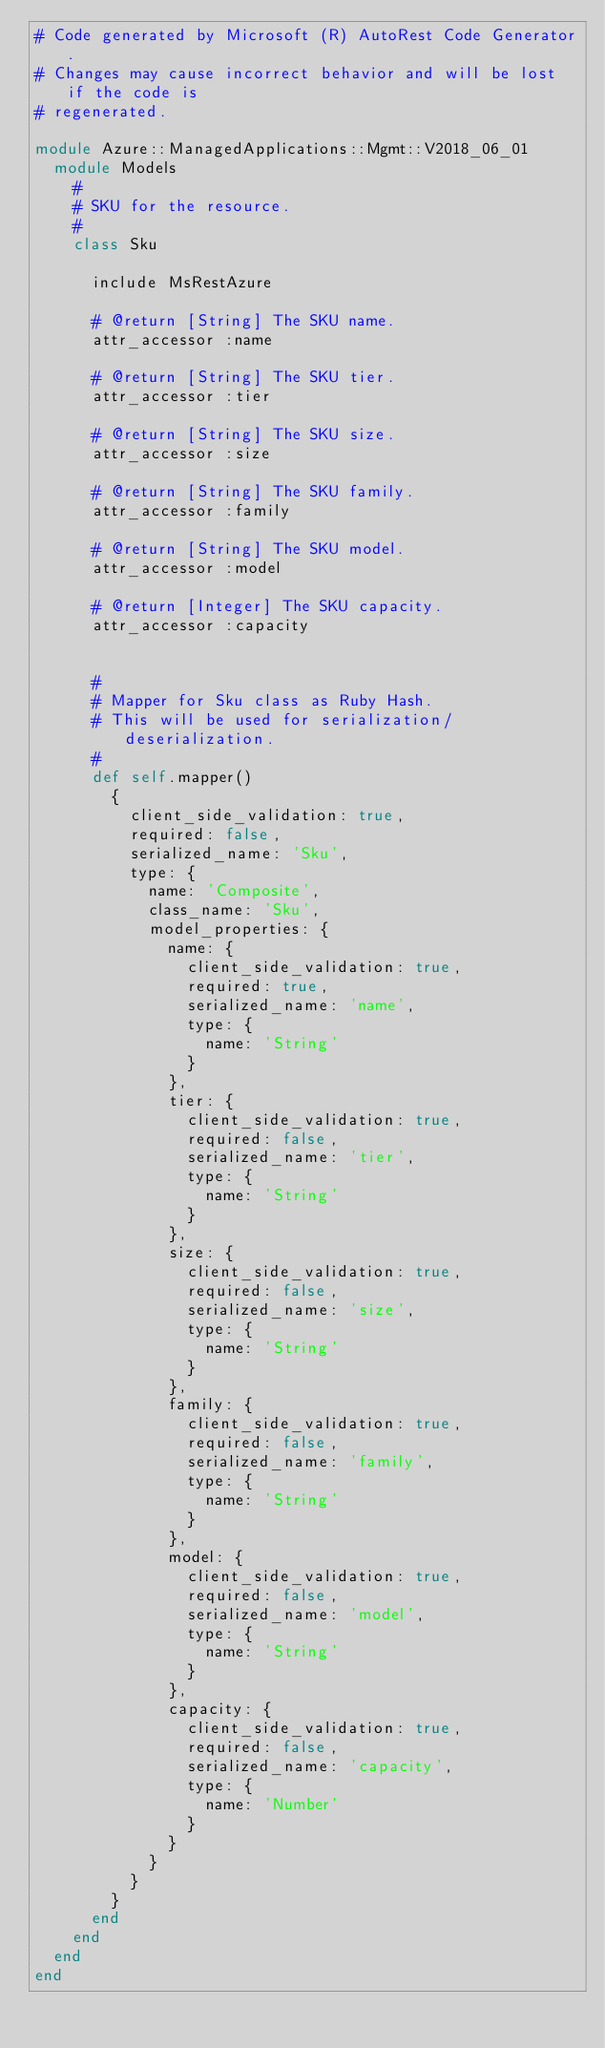<code> <loc_0><loc_0><loc_500><loc_500><_Ruby_># Code generated by Microsoft (R) AutoRest Code Generator.
# Changes may cause incorrect behavior and will be lost if the code is
# regenerated.

module Azure::ManagedApplications::Mgmt::V2018_06_01
  module Models
    #
    # SKU for the resource.
    #
    class Sku

      include MsRestAzure

      # @return [String] The SKU name.
      attr_accessor :name

      # @return [String] The SKU tier.
      attr_accessor :tier

      # @return [String] The SKU size.
      attr_accessor :size

      # @return [String] The SKU family.
      attr_accessor :family

      # @return [String] The SKU model.
      attr_accessor :model

      # @return [Integer] The SKU capacity.
      attr_accessor :capacity


      #
      # Mapper for Sku class as Ruby Hash.
      # This will be used for serialization/deserialization.
      #
      def self.mapper()
        {
          client_side_validation: true,
          required: false,
          serialized_name: 'Sku',
          type: {
            name: 'Composite',
            class_name: 'Sku',
            model_properties: {
              name: {
                client_side_validation: true,
                required: true,
                serialized_name: 'name',
                type: {
                  name: 'String'
                }
              },
              tier: {
                client_side_validation: true,
                required: false,
                serialized_name: 'tier',
                type: {
                  name: 'String'
                }
              },
              size: {
                client_side_validation: true,
                required: false,
                serialized_name: 'size',
                type: {
                  name: 'String'
                }
              },
              family: {
                client_side_validation: true,
                required: false,
                serialized_name: 'family',
                type: {
                  name: 'String'
                }
              },
              model: {
                client_side_validation: true,
                required: false,
                serialized_name: 'model',
                type: {
                  name: 'String'
                }
              },
              capacity: {
                client_side_validation: true,
                required: false,
                serialized_name: 'capacity',
                type: {
                  name: 'Number'
                }
              }
            }
          }
        }
      end
    end
  end
end
</code> 